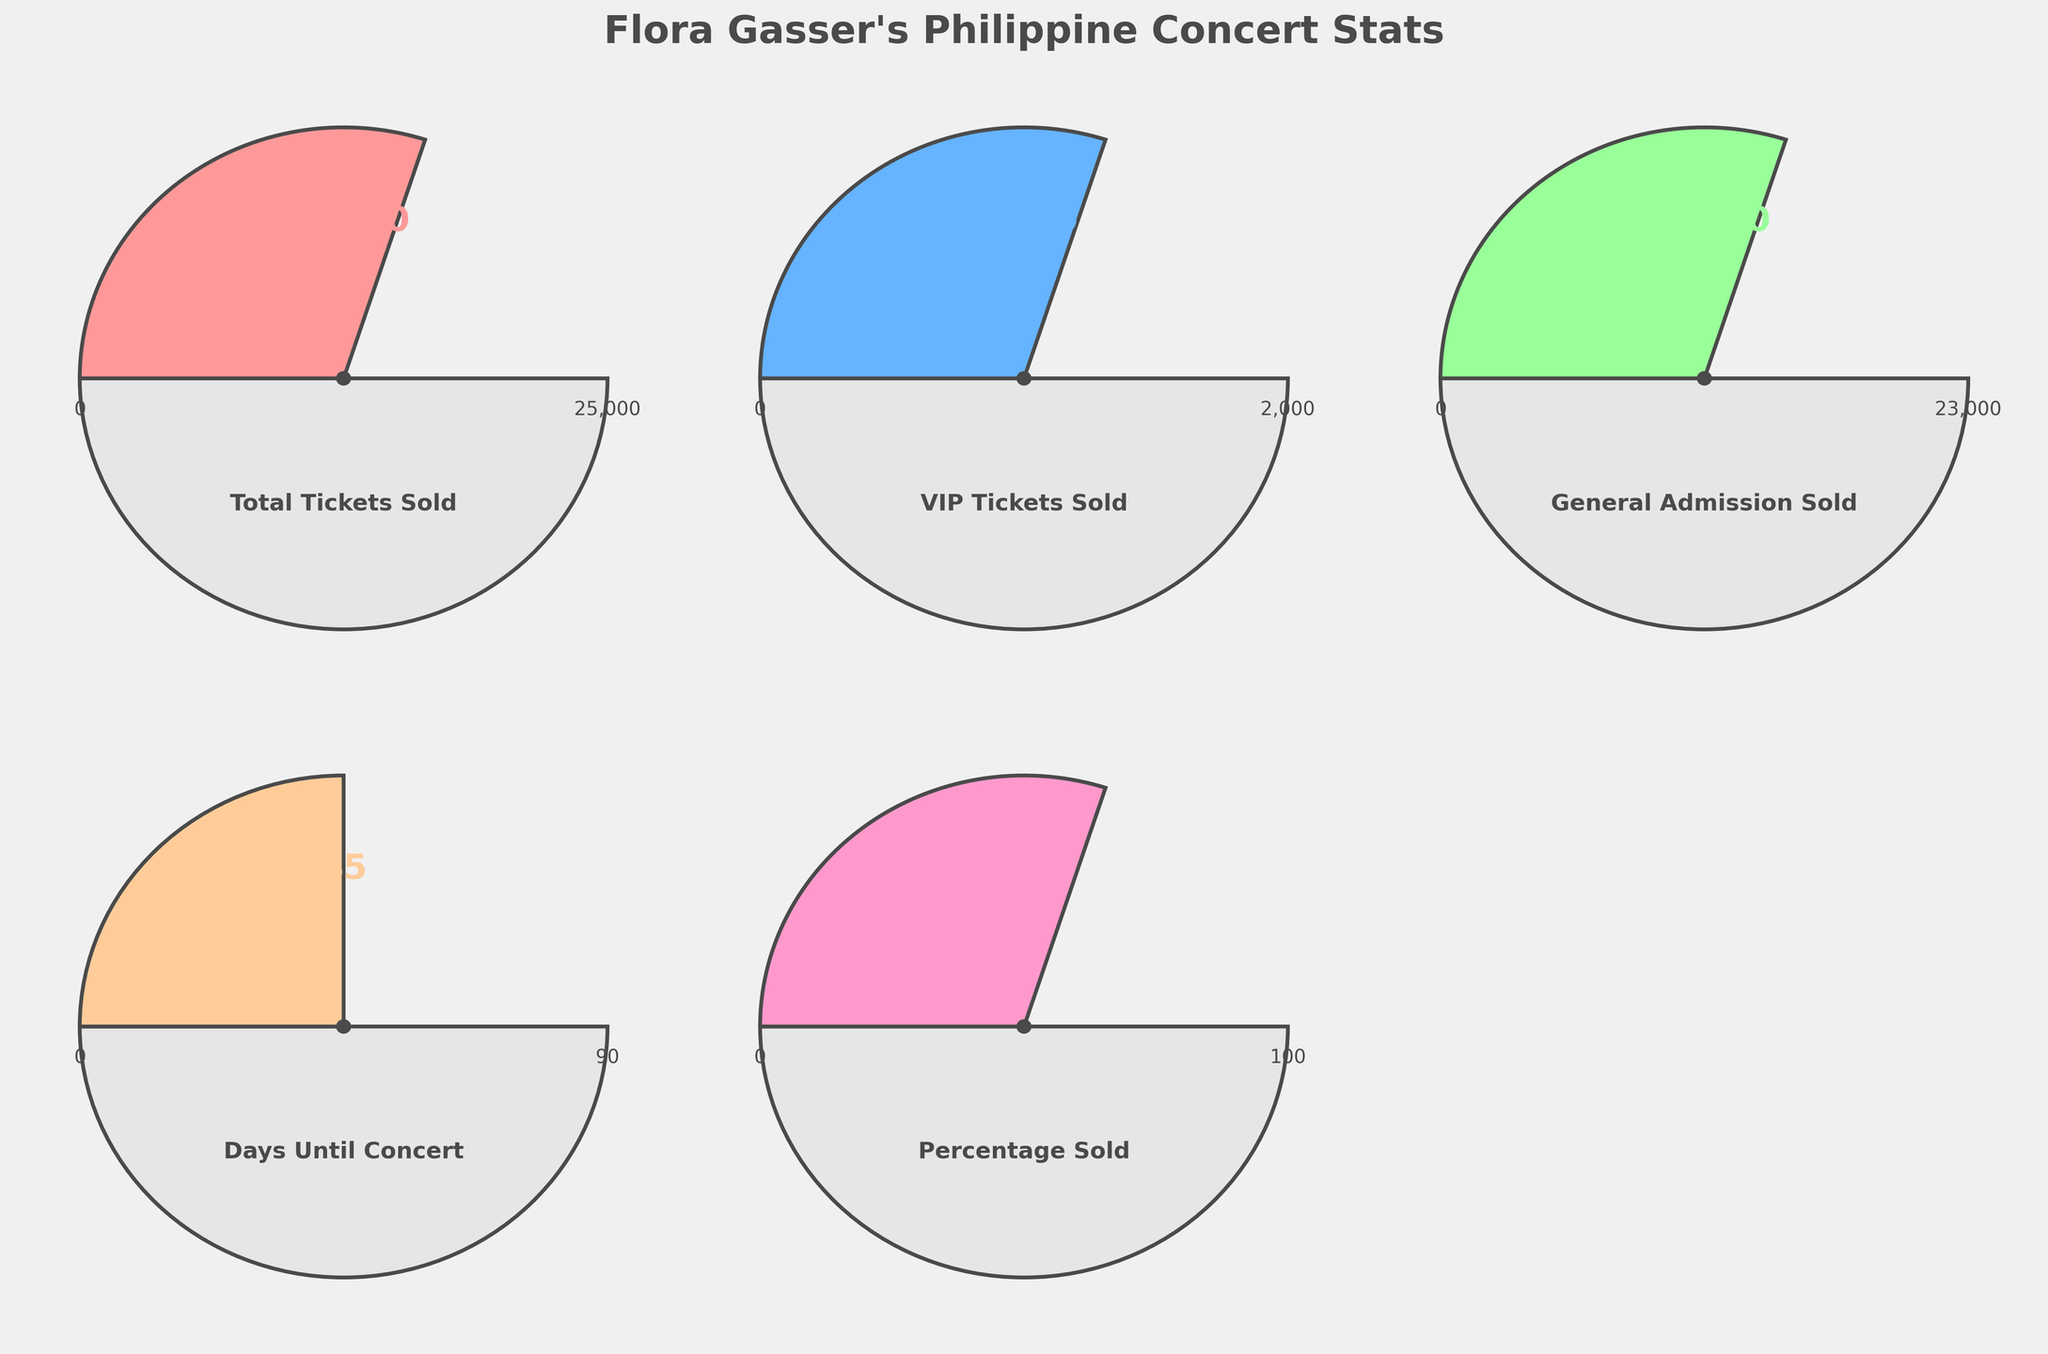What is the total number of tickets sold for Flora Gasser's next concert? The gauge for "Total Tickets Sold" shows a value of 15,000. Therefore, the total number of tickets sold is 15,000.
Answer: 15,000 What percentage of tickets has been sold for the concert? The "Percentage Sold" gauge displays a value of 60%. Therefore, 60% of the tickets has been sold for the concert.
Answer: 60% How many VIP tickets have been sold? The gauge for "VIP Tickets Sold" indicates a value of 1,200. Therefore, 1,200 VIP tickets have been sold.
Answer: 1,200 How many general admission tickets have been sold compared to VIP tickets? The "General Admission Sold" gauge shows 13,800 tickets sold and the "VIP Tickets Sold" gauge shows 1,200 tickets sold. Subtracting VIP tickets from General Admission tickets gives 13,800 - 1,200 = 12,600.
Answer: 12,600 What is the range of days left until the concert? The "Days Until Concert" gauge is based on a range from 0 to 90 days, as shown in the visual.
Answer: 0 to 90 days What is the maximum capacity of general admission tickets for the concert? The "General Admission Sold" gauge shows the maximum value is 23,000 tickets. Therefore, the maximum capacity is 23,000 tickets.
Answer: 23,000 How does the percentage of sold tickets compare to the total number of tickets sold? The "Percentage Sold" gauge shows 60% sold, and the "Total Tickets Sold" gauge shows 15,000 tickets sold. Therefore, 60% of the total tickets (which corresponds to 15,000 tickets) have been sold.
Answer: 60% Between VIP and general admission, which ticket type has more sold tickets? The gauge for "General Admission Sold" shows 13,800 tickets sold compared to 1,200 VIP tickets sold according to the "VIP Tickets Sold" gauge. Thus, general admission has more sold tickets.
Answer: General admission What is the average number of tickets sold per day until the concert? The "Total Tickets Sold" gauge shows 15,000 sold tickets and the "Days Until Concert" gauge shows 45 days left. Dividing the number of tickets by the number of days gives 15,000 / 45 = 333.33 tickets per day.
Answer: Approximately 333 tickets per day 